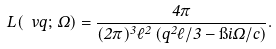Convert formula to latex. <formula><loc_0><loc_0><loc_500><loc_500>L ( \ v q ; \, \Omega ) = \frac { 4 \pi } { ( 2 \pi ) ^ { 3 } \ell ^ { 2 } \left ( q ^ { 2 } \ell / 3 - \i i \Omega / c \right ) } .</formula> 